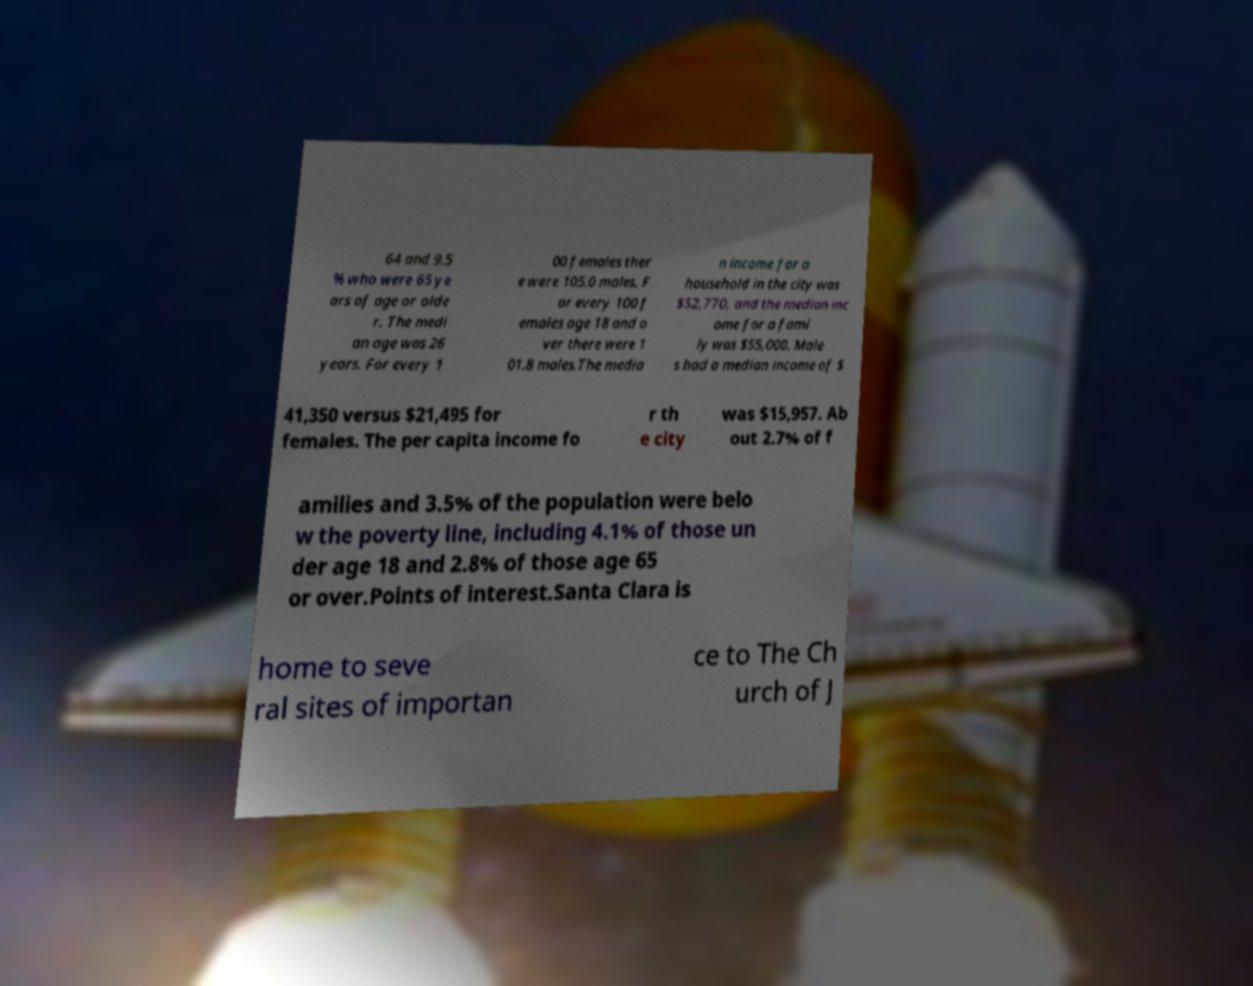Could you assist in decoding the text presented in this image and type it out clearly? 64 and 9.5 % who were 65 ye ars of age or olde r. The medi an age was 26 years. For every 1 00 females ther e were 105.0 males. F or every 100 f emales age 18 and o ver there were 1 01.8 males.The media n income for a household in the city was $52,770, and the median inc ome for a fami ly was $55,000. Male s had a median income of $ 41,350 versus $21,495 for females. The per capita income fo r th e city was $15,957. Ab out 2.7% of f amilies and 3.5% of the population were belo w the poverty line, including 4.1% of those un der age 18 and 2.8% of those age 65 or over.Points of interest.Santa Clara is home to seve ral sites of importan ce to The Ch urch of J 